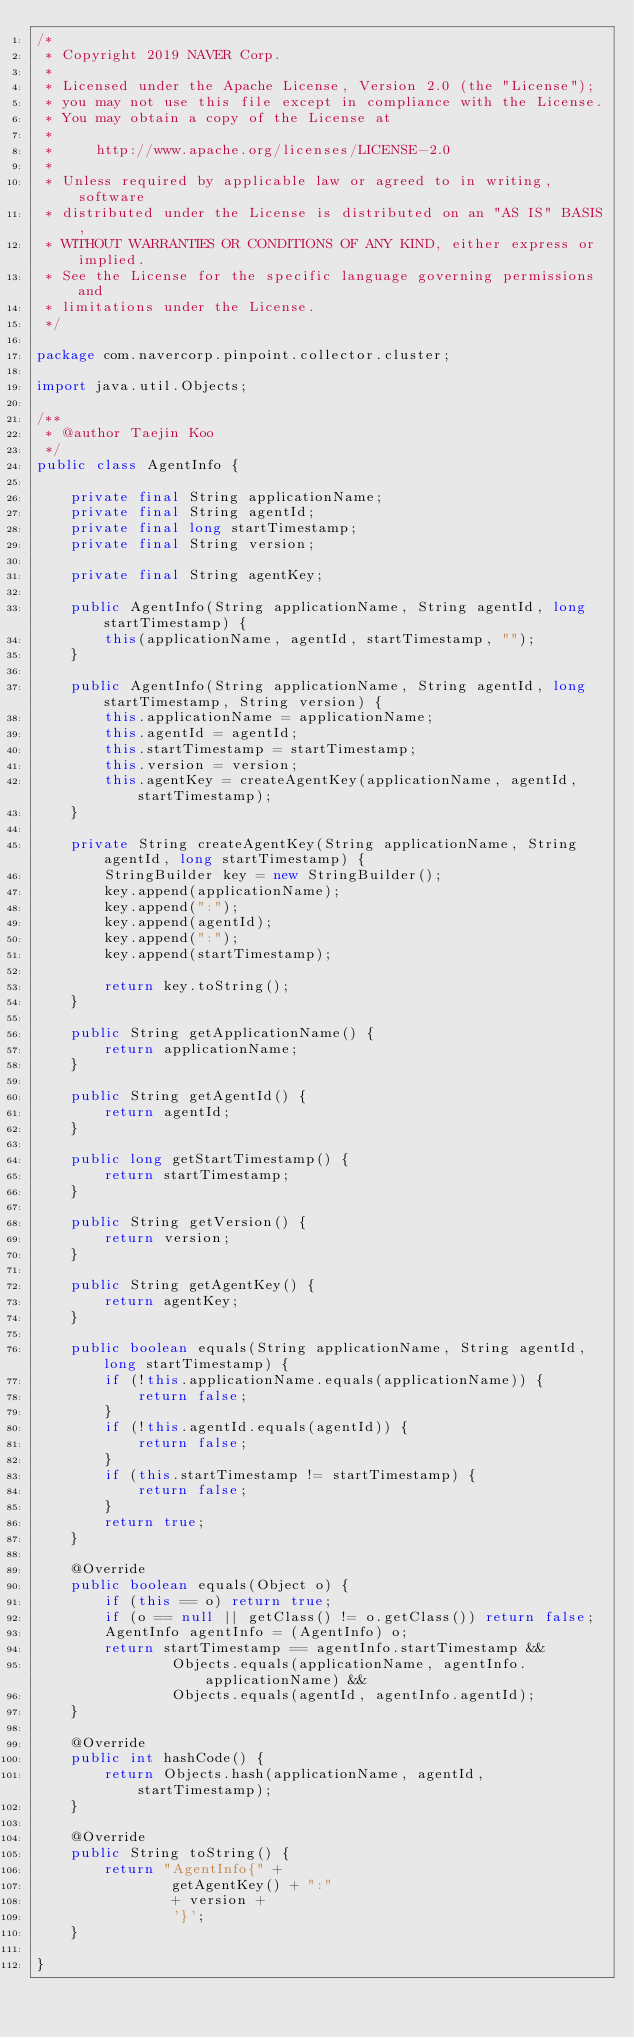<code> <loc_0><loc_0><loc_500><loc_500><_Java_>/*
 * Copyright 2019 NAVER Corp.
 *
 * Licensed under the Apache License, Version 2.0 (the "License");
 * you may not use this file except in compliance with the License.
 * You may obtain a copy of the License at
 *
 *     http://www.apache.org/licenses/LICENSE-2.0
 *
 * Unless required by applicable law or agreed to in writing, software
 * distributed under the License is distributed on an "AS IS" BASIS,
 * WITHOUT WARRANTIES OR CONDITIONS OF ANY KIND, either express or implied.
 * See the License for the specific language governing permissions and
 * limitations under the License.
 */

package com.navercorp.pinpoint.collector.cluster;

import java.util.Objects;

/**
 * @author Taejin Koo
 */
public class AgentInfo {

    private final String applicationName;
    private final String agentId;
    private final long startTimestamp;
    private final String version;

    private final String agentKey;

    public AgentInfo(String applicationName, String agentId, long startTimestamp) {
        this(applicationName, agentId, startTimestamp, "");
    }

    public AgentInfo(String applicationName, String agentId, long startTimestamp, String version) {
        this.applicationName = applicationName;
        this.agentId = agentId;
        this.startTimestamp = startTimestamp;
        this.version = version;
        this.agentKey = createAgentKey(applicationName, agentId, startTimestamp);
    }

    private String createAgentKey(String applicationName, String agentId, long startTimestamp) {
        StringBuilder key = new StringBuilder();
        key.append(applicationName);
        key.append(":");
        key.append(agentId);
        key.append(":");
        key.append(startTimestamp);

        return key.toString();
    }

    public String getApplicationName() {
        return applicationName;
    }

    public String getAgentId() {
        return agentId;
    }

    public long getStartTimestamp() {
        return startTimestamp;
    }

    public String getVersion() {
        return version;
    }

    public String getAgentKey() {
        return agentKey;
    }

    public boolean equals(String applicationName, String agentId, long startTimestamp) {
        if (!this.applicationName.equals(applicationName)) {
            return false;
        }
        if (!this.agentId.equals(agentId)) {
            return false;
        }
        if (this.startTimestamp != startTimestamp) {
            return false;
        }
        return true;
    }

    @Override
    public boolean equals(Object o) {
        if (this == o) return true;
        if (o == null || getClass() != o.getClass()) return false;
        AgentInfo agentInfo = (AgentInfo) o;
        return startTimestamp == agentInfo.startTimestamp &&
                Objects.equals(applicationName, agentInfo.applicationName) &&
                Objects.equals(agentId, agentInfo.agentId);
    }

    @Override
    public int hashCode() {
        return Objects.hash(applicationName, agentId, startTimestamp);
    }

    @Override
    public String toString() {
        return "AgentInfo{" +
                getAgentKey() + ":"
                + version +
                '}';
    }

}
</code> 